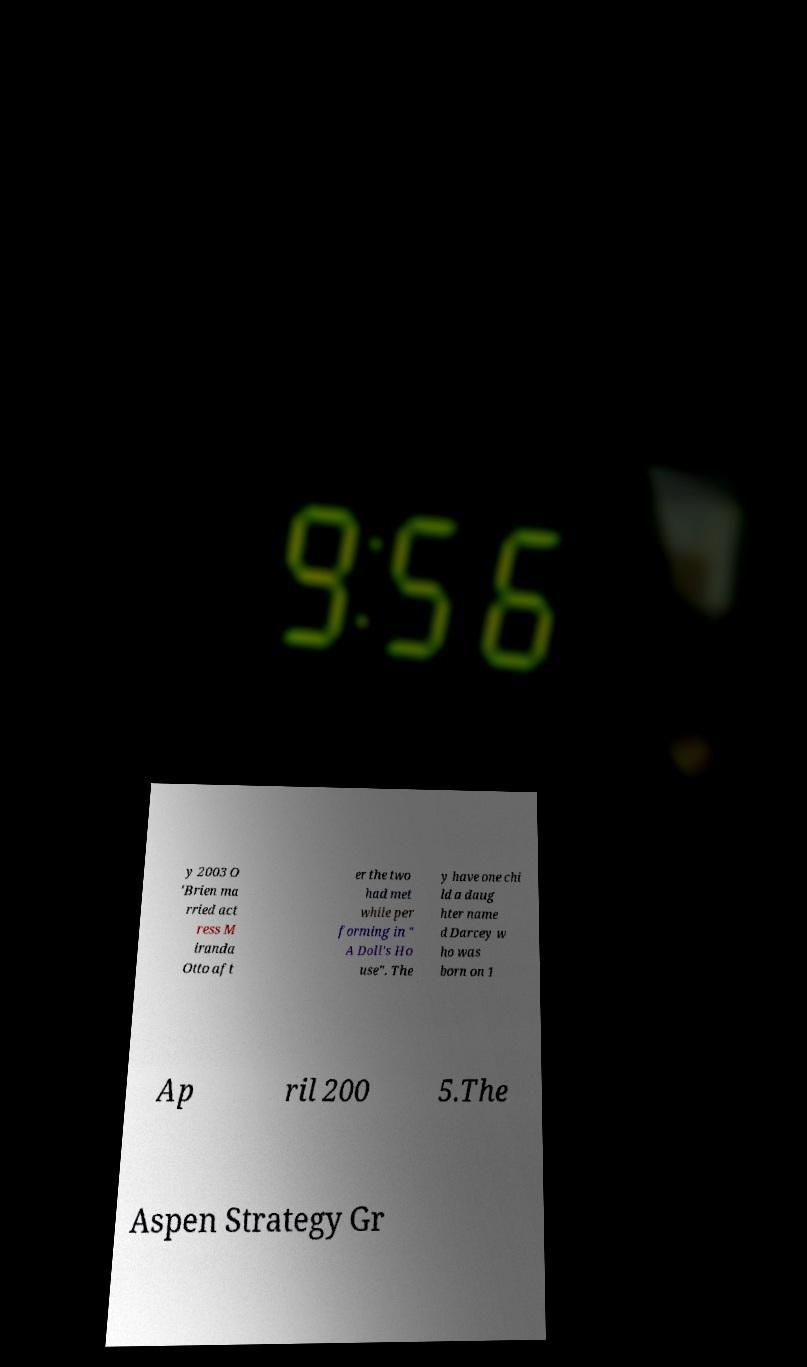I need the written content from this picture converted into text. Can you do that? y 2003 O 'Brien ma rried act ress M iranda Otto aft er the two had met while per forming in " A Doll's Ho use". The y have one chi ld a daug hter name d Darcey w ho was born on 1 Ap ril 200 5.The Aspen Strategy Gr 